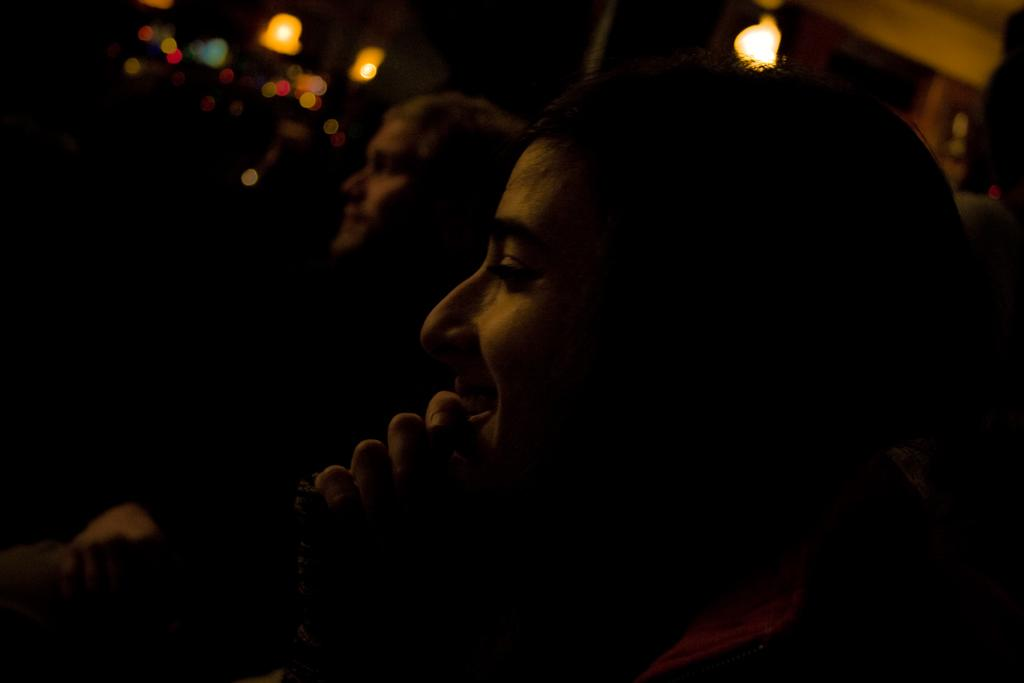What are the people in the image doing? The people in the image are sitting. What can be seen in the image besides the people? There are lights visible in the image. What type of pest can be seen crawling on the people in the image? There is no pest visible in the image; the people are sitting without any pests present. 